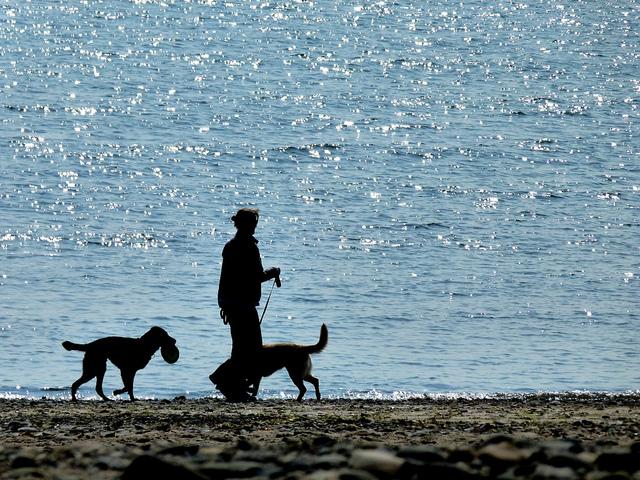How many dogs are there?
Short answer required. 2. What animals are by the water?
Short answer required. Dogs. What is the location of the picture?
Concise answer only. Beach. How many people are there?
Give a very brief answer. 1. What animals are swimming?
Concise answer only. Dogs. Is the dog on the left smaller than the dog on the right?
Give a very brief answer. No. 